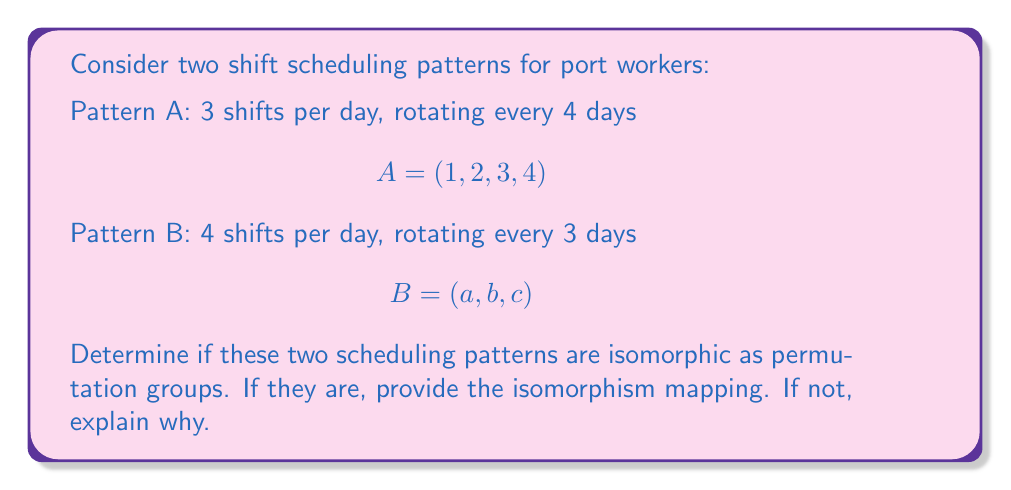Can you solve this math problem? To determine if the two shift scheduling patterns are isomorphic as permutation groups, we need to analyze their group structures:

1. Order of the groups:
   - Pattern A: $|A| = 4$
   - Pattern B: $|B| = 3$

2. Cycle structure:
   - Pattern A: $(1234)$ is a 4-cycle
   - Pattern B: $(abc)$ is a 3-cycle

3. Group properties:
   - Both groups are cyclic groups generated by a single element.
   - $A \cong C_4$ (cyclic group of order 4)
   - $B \cong C_3$ (cyclic group of order 3)

4. Isomorphism conditions:
   For two groups to be isomorphic, they must have:
   a) The same order
   b) The same cycle structure
   c) A bijective homomorphism between them

In this case, the groups fail condition (a) as they have different orders: $|A| = 4 \neq 3 = |B|$

Additionally, they have different cycle structures: a 4-cycle cannot be isomorphic to a 3-cycle.

Therefore, the two shift scheduling patterns are not isomorphic as permutation groups.
Answer: The two shift scheduling patterns are not isomorphic as permutation groups because they have different orders ($|A| = 4$ and $|B| = 3$) and different cycle structures (4-cycle vs. 3-cycle). 